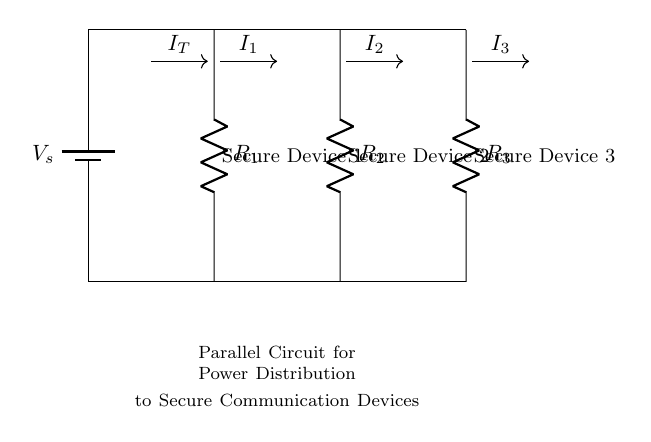What type of circuit is shown in the diagram? The diagram represents a parallel circuit, where multiple components are connected in parallel to share the same voltage.
Answer: Parallel circuit What are the resistors labeled in the circuit? The circuit includes three resistors labeled R1, R2, and R3, which can each handle the current intended for their corresponding secure devices.
Answer: R1, R2, R3 What is the total current entering the circuit? The total current entering a parallel circuit is represented as I_T in the diagram, which is the sum of the individual currents through each resistor, I1, I2, and I3.
Answer: I_T How would the voltage across each resistor compare to the source voltage? In a parallel circuit, the voltage across each component equals the source voltage, so the voltage across R1, R2, and R3 will all be equal to the source voltage annotated as V_s.
Answer: V_s What can be said about the current flowing through each resistor relative to its resistance? The current flowing through each resistor is inversely proportional to its resistance, meaning lower resistance results in higher current, which is a characteristic of a current divider in a parallel circuit.
Answer: Inversely proportional What is the function of the circuit in relation to the secure devices? The primary function of the circuit is to distribute power equally across multiple secure communication devices, ensuring each device receives the required voltage.
Answer: Power distribution 